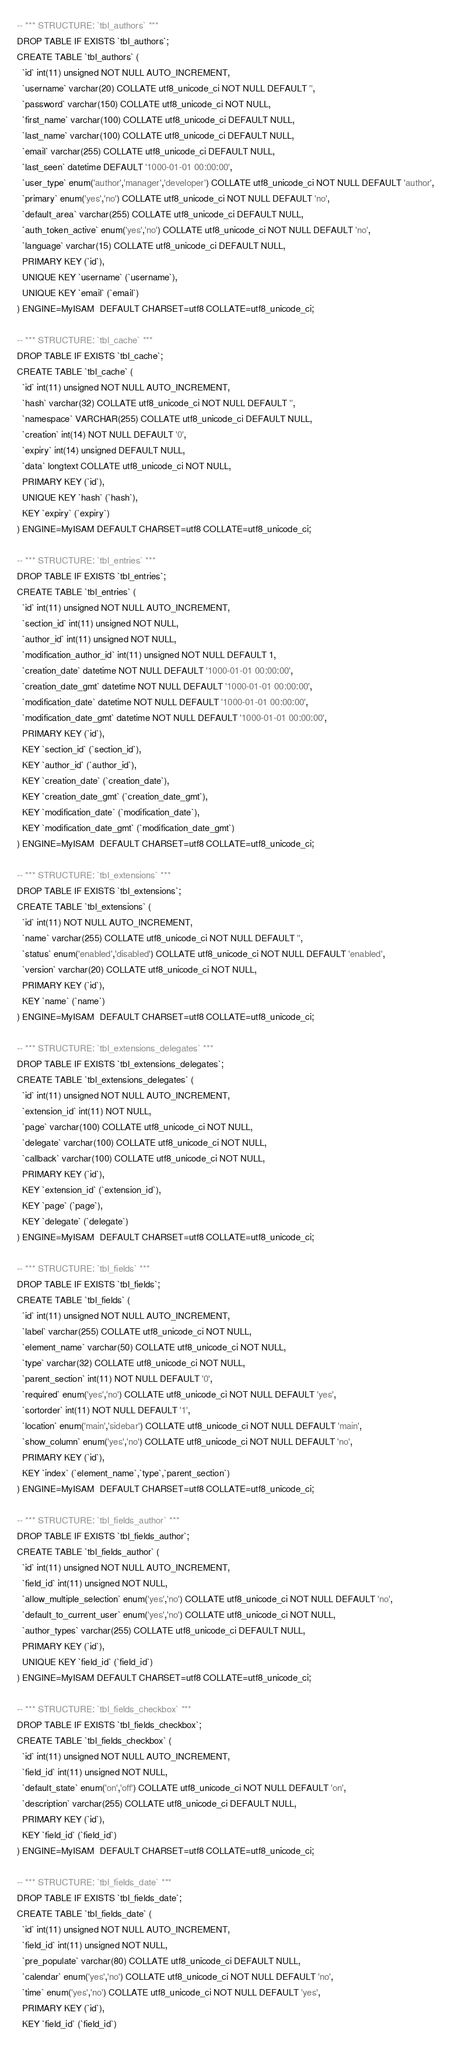<code> <loc_0><loc_0><loc_500><loc_500><_SQL_>-- *** STRUCTURE: `tbl_authors` ***
DROP TABLE IF EXISTS `tbl_authors`;
CREATE TABLE `tbl_authors` (
  `id` int(11) unsigned NOT NULL AUTO_INCREMENT,
  `username` varchar(20) COLLATE utf8_unicode_ci NOT NULL DEFAULT '',
  `password` varchar(150) COLLATE utf8_unicode_ci NOT NULL,
  `first_name` varchar(100) COLLATE utf8_unicode_ci DEFAULT NULL,
  `last_name` varchar(100) COLLATE utf8_unicode_ci DEFAULT NULL,
  `email` varchar(255) COLLATE utf8_unicode_ci DEFAULT NULL,
  `last_seen` datetime DEFAULT '1000-01-01 00:00:00',
  `user_type` enum('author','manager','developer') COLLATE utf8_unicode_ci NOT NULL DEFAULT 'author',
  `primary` enum('yes','no') COLLATE utf8_unicode_ci NOT NULL DEFAULT 'no',
  `default_area` varchar(255) COLLATE utf8_unicode_ci DEFAULT NULL,
  `auth_token_active` enum('yes','no') COLLATE utf8_unicode_ci NOT NULL DEFAULT 'no',
  `language` varchar(15) COLLATE utf8_unicode_ci DEFAULT NULL,
  PRIMARY KEY (`id`),
  UNIQUE KEY `username` (`username`),
  UNIQUE KEY `email` (`email`)
) ENGINE=MyISAM  DEFAULT CHARSET=utf8 COLLATE=utf8_unicode_ci;

-- *** STRUCTURE: `tbl_cache` ***
DROP TABLE IF EXISTS `tbl_cache`;
CREATE TABLE `tbl_cache` (
  `id` int(11) unsigned NOT NULL AUTO_INCREMENT,
  `hash` varchar(32) COLLATE utf8_unicode_ci NOT NULL DEFAULT '',
  `namespace` VARCHAR(255) COLLATE utf8_unicode_ci DEFAULT NULL,
  `creation` int(14) NOT NULL DEFAULT '0',
  `expiry` int(14) unsigned DEFAULT NULL,
  `data` longtext COLLATE utf8_unicode_ci NOT NULL,
  PRIMARY KEY (`id`),
  UNIQUE KEY `hash` (`hash`),
  KEY `expiry` (`expiry`)
) ENGINE=MyISAM DEFAULT CHARSET=utf8 COLLATE=utf8_unicode_ci;

-- *** STRUCTURE: `tbl_entries` ***
DROP TABLE IF EXISTS `tbl_entries`;
CREATE TABLE `tbl_entries` (
  `id` int(11) unsigned NOT NULL AUTO_INCREMENT,
  `section_id` int(11) unsigned NOT NULL,
  `author_id` int(11) unsigned NOT NULL,
  `modification_author_id` int(11) unsigned NOT NULL DEFAULT 1,
  `creation_date` datetime NOT NULL DEFAULT '1000-01-01 00:00:00',
  `creation_date_gmt` datetime NOT NULL DEFAULT '1000-01-01 00:00:00',
  `modification_date` datetime NOT NULL DEFAULT '1000-01-01 00:00:00',
  `modification_date_gmt` datetime NOT NULL DEFAULT '1000-01-01 00:00:00',
  PRIMARY KEY (`id`),
  KEY `section_id` (`section_id`),
  KEY `author_id` (`author_id`),
  KEY `creation_date` (`creation_date`),
  KEY `creation_date_gmt` (`creation_date_gmt`),
  KEY `modification_date` (`modification_date`),
  KEY `modification_date_gmt` (`modification_date_gmt`)
) ENGINE=MyISAM  DEFAULT CHARSET=utf8 COLLATE=utf8_unicode_ci;

-- *** STRUCTURE: `tbl_extensions` ***
DROP TABLE IF EXISTS `tbl_extensions`;
CREATE TABLE `tbl_extensions` (
  `id` int(11) NOT NULL AUTO_INCREMENT,
  `name` varchar(255) COLLATE utf8_unicode_ci NOT NULL DEFAULT '',
  `status` enum('enabled','disabled') COLLATE utf8_unicode_ci NOT NULL DEFAULT 'enabled',
  `version` varchar(20) COLLATE utf8_unicode_ci NOT NULL,
  PRIMARY KEY (`id`),
  KEY `name` (`name`)
) ENGINE=MyISAM  DEFAULT CHARSET=utf8 COLLATE=utf8_unicode_ci;

-- *** STRUCTURE: `tbl_extensions_delegates` ***
DROP TABLE IF EXISTS `tbl_extensions_delegates`;
CREATE TABLE `tbl_extensions_delegates` (
  `id` int(11) unsigned NOT NULL AUTO_INCREMENT,
  `extension_id` int(11) NOT NULL,
  `page` varchar(100) COLLATE utf8_unicode_ci NOT NULL,
  `delegate` varchar(100) COLLATE utf8_unicode_ci NOT NULL,
  `callback` varchar(100) COLLATE utf8_unicode_ci NOT NULL,
  PRIMARY KEY (`id`),
  KEY `extension_id` (`extension_id`),
  KEY `page` (`page`),
  KEY `delegate` (`delegate`)
) ENGINE=MyISAM  DEFAULT CHARSET=utf8 COLLATE=utf8_unicode_ci;

-- *** STRUCTURE: `tbl_fields` ***
DROP TABLE IF EXISTS `tbl_fields`;
CREATE TABLE `tbl_fields` (
  `id` int(11) unsigned NOT NULL AUTO_INCREMENT,
  `label` varchar(255) COLLATE utf8_unicode_ci NOT NULL,
  `element_name` varchar(50) COLLATE utf8_unicode_ci NOT NULL,
  `type` varchar(32) COLLATE utf8_unicode_ci NOT NULL,
  `parent_section` int(11) NOT NULL DEFAULT '0',
  `required` enum('yes','no') COLLATE utf8_unicode_ci NOT NULL DEFAULT 'yes',
  `sortorder` int(11) NOT NULL DEFAULT '1',
  `location` enum('main','sidebar') COLLATE utf8_unicode_ci NOT NULL DEFAULT 'main',
  `show_column` enum('yes','no') COLLATE utf8_unicode_ci NOT NULL DEFAULT 'no',
  PRIMARY KEY (`id`),
  KEY `index` (`element_name`,`type`,`parent_section`)
) ENGINE=MyISAM  DEFAULT CHARSET=utf8 COLLATE=utf8_unicode_ci;

-- *** STRUCTURE: `tbl_fields_author` ***
DROP TABLE IF EXISTS `tbl_fields_author`;
CREATE TABLE `tbl_fields_author` (
  `id` int(11) unsigned NOT NULL AUTO_INCREMENT,
  `field_id` int(11) unsigned NOT NULL,
  `allow_multiple_selection` enum('yes','no') COLLATE utf8_unicode_ci NOT NULL DEFAULT 'no',
  `default_to_current_user` enum('yes','no') COLLATE utf8_unicode_ci NOT NULL,
  `author_types` varchar(255) COLLATE utf8_unicode_ci DEFAULT NULL,
  PRIMARY KEY (`id`),
  UNIQUE KEY `field_id` (`field_id`)
) ENGINE=MyISAM DEFAULT CHARSET=utf8 COLLATE=utf8_unicode_ci;

-- *** STRUCTURE: `tbl_fields_checkbox` ***
DROP TABLE IF EXISTS `tbl_fields_checkbox`;
CREATE TABLE `tbl_fields_checkbox` (
  `id` int(11) unsigned NOT NULL AUTO_INCREMENT,
  `field_id` int(11) unsigned NOT NULL,
  `default_state` enum('on','off') COLLATE utf8_unicode_ci NOT NULL DEFAULT 'on',
  `description` varchar(255) COLLATE utf8_unicode_ci DEFAULT NULL,
  PRIMARY KEY (`id`),
  KEY `field_id` (`field_id`)
) ENGINE=MyISAM  DEFAULT CHARSET=utf8 COLLATE=utf8_unicode_ci;

-- *** STRUCTURE: `tbl_fields_date` ***
DROP TABLE IF EXISTS `tbl_fields_date`;
CREATE TABLE `tbl_fields_date` (
  `id` int(11) unsigned NOT NULL AUTO_INCREMENT,
  `field_id` int(11) unsigned NOT NULL,
  `pre_populate` varchar(80) COLLATE utf8_unicode_ci DEFAULT NULL,
  `calendar` enum('yes','no') COLLATE utf8_unicode_ci NOT NULL DEFAULT 'no',
  `time` enum('yes','no') COLLATE utf8_unicode_ci NOT NULL DEFAULT 'yes',
  PRIMARY KEY (`id`),
  KEY `field_id` (`field_id`)</code> 